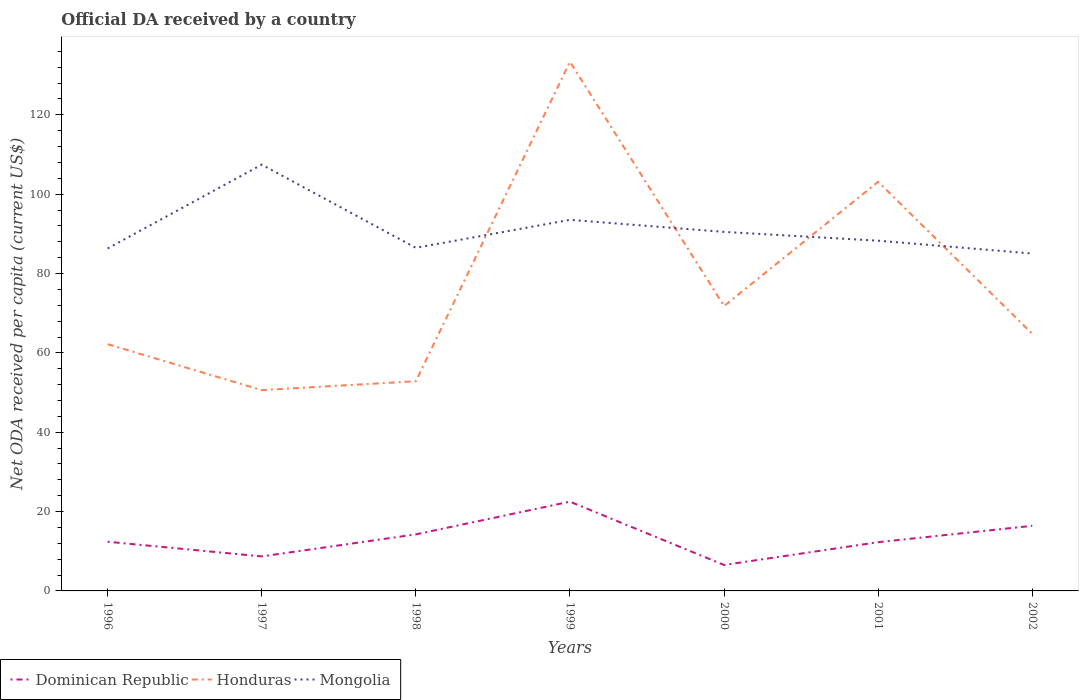How many different coloured lines are there?
Your response must be concise. 3. Does the line corresponding to Dominican Republic intersect with the line corresponding to Mongolia?
Provide a succinct answer. No. Across all years, what is the maximum ODA received in in Honduras?
Ensure brevity in your answer.  50.61. What is the total ODA received in in Mongolia in the graph?
Provide a short and direct response. 1.44. What is the difference between the highest and the second highest ODA received in in Mongolia?
Provide a succinct answer. 22.4. What is the difference between the highest and the lowest ODA received in in Dominican Republic?
Ensure brevity in your answer.  3. How many lines are there?
Make the answer very short. 3. What is the difference between two consecutive major ticks on the Y-axis?
Provide a succinct answer. 20. Does the graph contain any zero values?
Ensure brevity in your answer.  No. Where does the legend appear in the graph?
Ensure brevity in your answer.  Bottom left. How many legend labels are there?
Make the answer very short. 3. What is the title of the graph?
Your response must be concise. Official DA received by a country. What is the label or title of the X-axis?
Give a very brief answer. Years. What is the label or title of the Y-axis?
Keep it short and to the point. Net ODA received per capita (current US$). What is the Net ODA received per capita (current US$) in Dominican Republic in 1996?
Make the answer very short. 12.39. What is the Net ODA received per capita (current US$) in Honduras in 1996?
Provide a succinct answer. 62.19. What is the Net ODA received per capita (current US$) in Mongolia in 1996?
Offer a terse response. 86.32. What is the Net ODA received per capita (current US$) in Dominican Republic in 1997?
Your response must be concise. 8.7. What is the Net ODA received per capita (current US$) in Honduras in 1997?
Give a very brief answer. 50.61. What is the Net ODA received per capita (current US$) of Mongolia in 1997?
Provide a short and direct response. 107.45. What is the Net ODA received per capita (current US$) in Dominican Republic in 1998?
Give a very brief answer. 14.25. What is the Net ODA received per capita (current US$) in Honduras in 1998?
Keep it short and to the point. 52.86. What is the Net ODA received per capita (current US$) of Mongolia in 1998?
Make the answer very short. 86.48. What is the Net ODA received per capita (current US$) of Dominican Republic in 1999?
Give a very brief answer. 22.5. What is the Net ODA received per capita (current US$) of Honduras in 1999?
Make the answer very short. 133.39. What is the Net ODA received per capita (current US$) in Mongolia in 1999?
Offer a very short reply. 93.54. What is the Net ODA received per capita (current US$) of Dominican Republic in 2000?
Your answer should be compact. 6.54. What is the Net ODA received per capita (current US$) in Honduras in 2000?
Provide a short and direct response. 71.81. What is the Net ODA received per capita (current US$) in Mongolia in 2000?
Your answer should be compact. 90.5. What is the Net ODA received per capita (current US$) of Dominican Republic in 2001?
Your answer should be compact. 12.29. What is the Net ODA received per capita (current US$) of Honduras in 2001?
Your answer should be compact. 103.13. What is the Net ODA received per capita (current US$) of Mongolia in 2001?
Your response must be concise. 88.28. What is the Net ODA received per capita (current US$) in Dominican Republic in 2002?
Ensure brevity in your answer.  16.41. What is the Net ODA received per capita (current US$) of Honduras in 2002?
Keep it short and to the point. 64.8. What is the Net ODA received per capita (current US$) of Mongolia in 2002?
Your answer should be very brief. 85.04. Across all years, what is the maximum Net ODA received per capita (current US$) of Dominican Republic?
Give a very brief answer. 22.5. Across all years, what is the maximum Net ODA received per capita (current US$) in Honduras?
Your answer should be very brief. 133.39. Across all years, what is the maximum Net ODA received per capita (current US$) of Mongolia?
Offer a terse response. 107.45. Across all years, what is the minimum Net ODA received per capita (current US$) of Dominican Republic?
Provide a succinct answer. 6.54. Across all years, what is the minimum Net ODA received per capita (current US$) in Honduras?
Provide a succinct answer. 50.61. Across all years, what is the minimum Net ODA received per capita (current US$) of Mongolia?
Provide a succinct answer. 85.04. What is the total Net ODA received per capita (current US$) in Dominican Republic in the graph?
Provide a short and direct response. 93.08. What is the total Net ODA received per capita (current US$) of Honduras in the graph?
Give a very brief answer. 538.78. What is the total Net ODA received per capita (current US$) of Mongolia in the graph?
Your response must be concise. 637.6. What is the difference between the Net ODA received per capita (current US$) in Dominican Republic in 1996 and that in 1997?
Provide a short and direct response. 3.7. What is the difference between the Net ODA received per capita (current US$) in Honduras in 1996 and that in 1997?
Offer a terse response. 11.58. What is the difference between the Net ODA received per capita (current US$) of Mongolia in 1996 and that in 1997?
Your answer should be compact. -21.12. What is the difference between the Net ODA received per capita (current US$) of Dominican Republic in 1996 and that in 1998?
Ensure brevity in your answer.  -1.86. What is the difference between the Net ODA received per capita (current US$) in Honduras in 1996 and that in 1998?
Offer a terse response. 9.34. What is the difference between the Net ODA received per capita (current US$) of Mongolia in 1996 and that in 1998?
Provide a succinct answer. -0.16. What is the difference between the Net ODA received per capita (current US$) in Dominican Republic in 1996 and that in 1999?
Keep it short and to the point. -10.1. What is the difference between the Net ODA received per capita (current US$) in Honduras in 1996 and that in 1999?
Make the answer very short. -71.19. What is the difference between the Net ODA received per capita (current US$) in Mongolia in 1996 and that in 1999?
Make the answer very short. -7.22. What is the difference between the Net ODA received per capita (current US$) of Dominican Republic in 1996 and that in 2000?
Give a very brief answer. 5.85. What is the difference between the Net ODA received per capita (current US$) of Honduras in 1996 and that in 2000?
Provide a succinct answer. -9.61. What is the difference between the Net ODA received per capita (current US$) in Mongolia in 1996 and that in 2000?
Your answer should be very brief. -4.18. What is the difference between the Net ODA received per capita (current US$) in Dominican Republic in 1996 and that in 2001?
Your answer should be compact. 0.11. What is the difference between the Net ODA received per capita (current US$) in Honduras in 1996 and that in 2001?
Your answer should be very brief. -40.94. What is the difference between the Net ODA received per capita (current US$) in Mongolia in 1996 and that in 2001?
Make the answer very short. -1.96. What is the difference between the Net ODA received per capita (current US$) of Dominican Republic in 1996 and that in 2002?
Your answer should be very brief. -4.02. What is the difference between the Net ODA received per capita (current US$) of Honduras in 1996 and that in 2002?
Offer a terse response. -2.6. What is the difference between the Net ODA received per capita (current US$) in Mongolia in 1996 and that in 2002?
Your response must be concise. 1.28. What is the difference between the Net ODA received per capita (current US$) in Dominican Republic in 1997 and that in 1998?
Ensure brevity in your answer.  -5.55. What is the difference between the Net ODA received per capita (current US$) of Honduras in 1997 and that in 1998?
Your response must be concise. -2.25. What is the difference between the Net ODA received per capita (current US$) in Mongolia in 1997 and that in 1998?
Make the answer very short. 20.97. What is the difference between the Net ODA received per capita (current US$) of Dominican Republic in 1997 and that in 1999?
Your response must be concise. -13.8. What is the difference between the Net ODA received per capita (current US$) in Honduras in 1997 and that in 1999?
Offer a terse response. -82.78. What is the difference between the Net ODA received per capita (current US$) of Mongolia in 1997 and that in 1999?
Give a very brief answer. 13.91. What is the difference between the Net ODA received per capita (current US$) of Dominican Republic in 1997 and that in 2000?
Make the answer very short. 2.16. What is the difference between the Net ODA received per capita (current US$) of Honduras in 1997 and that in 2000?
Provide a short and direct response. -21.2. What is the difference between the Net ODA received per capita (current US$) in Mongolia in 1997 and that in 2000?
Keep it short and to the point. 16.95. What is the difference between the Net ODA received per capita (current US$) of Dominican Republic in 1997 and that in 2001?
Your response must be concise. -3.59. What is the difference between the Net ODA received per capita (current US$) of Honduras in 1997 and that in 2001?
Your answer should be very brief. -52.52. What is the difference between the Net ODA received per capita (current US$) of Mongolia in 1997 and that in 2001?
Offer a very short reply. 19.17. What is the difference between the Net ODA received per capita (current US$) in Dominican Republic in 1997 and that in 2002?
Give a very brief answer. -7.71. What is the difference between the Net ODA received per capita (current US$) of Honduras in 1997 and that in 2002?
Your answer should be very brief. -14.19. What is the difference between the Net ODA received per capita (current US$) in Mongolia in 1997 and that in 2002?
Offer a very short reply. 22.4. What is the difference between the Net ODA received per capita (current US$) of Dominican Republic in 1998 and that in 1999?
Make the answer very short. -8.25. What is the difference between the Net ODA received per capita (current US$) in Honduras in 1998 and that in 1999?
Provide a succinct answer. -80.53. What is the difference between the Net ODA received per capita (current US$) of Mongolia in 1998 and that in 1999?
Provide a short and direct response. -7.06. What is the difference between the Net ODA received per capita (current US$) in Dominican Republic in 1998 and that in 2000?
Give a very brief answer. 7.71. What is the difference between the Net ODA received per capita (current US$) in Honduras in 1998 and that in 2000?
Provide a short and direct response. -18.95. What is the difference between the Net ODA received per capita (current US$) in Mongolia in 1998 and that in 2000?
Give a very brief answer. -4.02. What is the difference between the Net ODA received per capita (current US$) in Dominican Republic in 1998 and that in 2001?
Ensure brevity in your answer.  1.96. What is the difference between the Net ODA received per capita (current US$) in Honduras in 1998 and that in 2001?
Ensure brevity in your answer.  -50.27. What is the difference between the Net ODA received per capita (current US$) in Mongolia in 1998 and that in 2001?
Provide a short and direct response. -1.8. What is the difference between the Net ODA received per capita (current US$) in Dominican Republic in 1998 and that in 2002?
Your response must be concise. -2.16. What is the difference between the Net ODA received per capita (current US$) in Honduras in 1998 and that in 2002?
Your answer should be very brief. -11.94. What is the difference between the Net ODA received per capita (current US$) in Mongolia in 1998 and that in 2002?
Your response must be concise. 1.44. What is the difference between the Net ODA received per capita (current US$) of Dominican Republic in 1999 and that in 2000?
Make the answer very short. 15.96. What is the difference between the Net ODA received per capita (current US$) of Honduras in 1999 and that in 2000?
Offer a terse response. 61.58. What is the difference between the Net ODA received per capita (current US$) in Mongolia in 1999 and that in 2000?
Offer a terse response. 3.04. What is the difference between the Net ODA received per capita (current US$) of Dominican Republic in 1999 and that in 2001?
Ensure brevity in your answer.  10.21. What is the difference between the Net ODA received per capita (current US$) in Honduras in 1999 and that in 2001?
Offer a very short reply. 30.26. What is the difference between the Net ODA received per capita (current US$) in Mongolia in 1999 and that in 2001?
Offer a very short reply. 5.26. What is the difference between the Net ODA received per capita (current US$) in Dominican Republic in 1999 and that in 2002?
Give a very brief answer. 6.09. What is the difference between the Net ODA received per capita (current US$) in Honduras in 1999 and that in 2002?
Make the answer very short. 68.59. What is the difference between the Net ODA received per capita (current US$) in Mongolia in 1999 and that in 2002?
Keep it short and to the point. 8.5. What is the difference between the Net ODA received per capita (current US$) in Dominican Republic in 2000 and that in 2001?
Provide a succinct answer. -5.75. What is the difference between the Net ODA received per capita (current US$) of Honduras in 2000 and that in 2001?
Offer a terse response. -31.32. What is the difference between the Net ODA received per capita (current US$) of Mongolia in 2000 and that in 2001?
Your response must be concise. 2.22. What is the difference between the Net ODA received per capita (current US$) in Dominican Republic in 2000 and that in 2002?
Offer a terse response. -9.87. What is the difference between the Net ODA received per capita (current US$) of Honduras in 2000 and that in 2002?
Offer a terse response. 7.01. What is the difference between the Net ODA received per capita (current US$) in Mongolia in 2000 and that in 2002?
Ensure brevity in your answer.  5.45. What is the difference between the Net ODA received per capita (current US$) of Dominican Republic in 2001 and that in 2002?
Offer a very short reply. -4.13. What is the difference between the Net ODA received per capita (current US$) in Honduras in 2001 and that in 2002?
Your response must be concise. 38.33. What is the difference between the Net ODA received per capita (current US$) in Mongolia in 2001 and that in 2002?
Provide a short and direct response. 3.24. What is the difference between the Net ODA received per capita (current US$) in Dominican Republic in 1996 and the Net ODA received per capita (current US$) in Honduras in 1997?
Offer a very short reply. -38.22. What is the difference between the Net ODA received per capita (current US$) of Dominican Republic in 1996 and the Net ODA received per capita (current US$) of Mongolia in 1997?
Provide a short and direct response. -95.05. What is the difference between the Net ODA received per capita (current US$) of Honduras in 1996 and the Net ODA received per capita (current US$) of Mongolia in 1997?
Ensure brevity in your answer.  -45.25. What is the difference between the Net ODA received per capita (current US$) of Dominican Republic in 1996 and the Net ODA received per capita (current US$) of Honduras in 1998?
Give a very brief answer. -40.46. What is the difference between the Net ODA received per capita (current US$) of Dominican Republic in 1996 and the Net ODA received per capita (current US$) of Mongolia in 1998?
Provide a short and direct response. -74.09. What is the difference between the Net ODA received per capita (current US$) in Honduras in 1996 and the Net ODA received per capita (current US$) in Mongolia in 1998?
Your response must be concise. -24.29. What is the difference between the Net ODA received per capita (current US$) of Dominican Republic in 1996 and the Net ODA received per capita (current US$) of Honduras in 1999?
Provide a succinct answer. -120.99. What is the difference between the Net ODA received per capita (current US$) of Dominican Republic in 1996 and the Net ODA received per capita (current US$) of Mongolia in 1999?
Ensure brevity in your answer.  -81.14. What is the difference between the Net ODA received per capita (current US$) in Honduras in 1996 and the Net ODA received per capita (current US$) in Mongolia in 1999?
Your response must be concise. -31.34. What is the difference between the Net ODA received per capita (current US$) in Dominican Republic in 1996 and the Net ODA received per capita (current US$) in Honduras in 2000?
Ensure brevity in your answer.  -59.41. What is the difference between the Net ODA received per capita (current US$) of Dominican Republic in 1996 and the Net ODA received per capita (current US$) of Mongolia in 2000?
Your answer should be compact. -78.1. What is the difference between the Net ODA received per capita (current US$) in Honduras in 1996 and the Net ODA received per capita (current US$) in Mongolia in 2000?
Provide a succinct answer. -28.3. What is the difference between the Net ODA received per capita (current US$) in Dominican Republic in 1996 and the Net ODA received per capita (current US$) in Honduras in 2001?
Provide a short and direct response. -90.74. What is the difference between the Net ODA received per capita (current US$) of Dominican Republic in 1996 and the Net ODA received per capita (current US$) of Mongolia in 2001?
Your response must be concise. -75.88. What is the difference between the Net ODA received per capita (current US$) in Honduras in 1996 and the Net ODA received per capita (current US$) in Mongolia in 2001?
Offer a terse response. -26.09. What is the difference between the Net ODA received per capita (current US$) in Dominican Republic in 1996 and the Net ODA received per capita (current US$) in Honduras in 2002?
Give a very brief answer. -52.4. What is the difference between the Net ODA received per capita (current US$) of Dominican Republic in 1996 and the Net ODA received per capita (current US$) of Mongolia in 2002?
Provide a succinct answer. -72.65. What is the difference between the Net ODA received per capita (current US$) in Honduras in 1996 and the Net ODA received per capita (current US$) in Mongolia in 2002?
Your answer should be very brief. -22.85. What is the difference between the Net ODA received per capita (current US$) of Dominican Republic in 1997 and the Net ODA received per capita (current US$) of Honduras in 1998?
Offer a very short reply. -44.16. What is the difference between the Net ODA received per capita (current US$) in Dominican Republic in 1997 and the Net ODA received per capita (current US$) in Mongolia in 1998?
Your response must be concise. -77.78. What is the difference between the Net ODA received per capita (current US$) in Honduras in 1997 and the Net ODA received per capita (current US$) in Mongolia in 1998?
Give a very brief answer. -35.87. What is the difference between the Net ODA received per capita (current US$) of Dominican Republic in 1997 and the Net ODA received per capita (current US$) of Honduras in 1999?
Keep it short and to the point. -124.69. What is the difference between the Net ODA received per capita (current US$) in Dominican Republic in 1997 and the Net ODA received per capita (current US$) in Mongolia in 1999?
Ensure brevity in your answer.  -84.84. What is the difference between the Net ODA received per capita (current US$) in Honduras in 1997 and the Net ODA received per capita (current US$) in Mongolia in 1999?
Provide a short and direct response. -42.93. What is the difference between the Net ODA received per capita (current US$) of Dominican Republic in 1997 and the Net ODA received per capita (current US$) of Honduras in 2000?
Your answer should be compact. -63.11. What is the difference between the Net ODA received per capita (current US$) in Dominican Republic in 1997 and the Net ODA received per capita (current US$) in Mongolia in 2000?
Keep it short and to the point. -81.8. What is the difference between the Net ODA received per capita (current US$) in Honduras in 1997 and the Net ODA received per capita (current US$) in Mongolia in 2000?
Offer a very short reply. -39.89. What is the difference between the Net ODA received per capita (current US$) in Dominican Republic in 1997 and the Net ODA received per capita (current US$) in Honduras in 2001?
Ensure brevity in your answer.  -94.43. What is the difference between the Net ODA received per capita (current US$) of Dominican Republic in 1997 and the Net ODA received per capita (current US$) of Mongolia in 2001?
Offer a very short reply. -79.58. What is the difference between the Net ODA received per capita (current US$) in Honduras in 1997 and the Net ODA received per capita (current US$) in Mongolia in 2001?
Provide a short and direct response. -37.67. What is the difference between the Net ODA received per capita (current US$) in Dominican Republic in 1997 and the Net ODA received per capita (current US$) in Honduras in 2002?
Keep it short and to the point. -56.1. What is the difference between the Net ODA received per capita (current US$) in Dominican Republic in 1997 and the Net ODA received per capita (current US$) in Mongolia in 2002?
Your answer should be very brief. -76.34. What is the difference between the Net ODA received per capita (current US$) in Honduras in 1997 and the Net ODA received per capita (current US$) in Mongolia in 2002?
Your response must be concise. -34.43. What is the difference between the Net ODA received per capita (current US$) in Dominican Republic in 1998 and the Net ODA received per capita (current US$) in Honduras in 1999?
Give a very brief answer. -119.13. What is the difference between the Net ODA received per capita (current US$) of Dominican Republic in 1998 and the Net ODA received per capita (current US$) of Mongolia in 1999?
Your response must be concise. -79.29. What is the difference between the Net ODA received per capita (current US$) in Honduras in 1998 and the Net ODA received per capita (current US$) in Mongolia in 1999?
Ensure brevity in your answer.  -40.68. What is the difference between the Net ODA received per capita (current US$) of Dominican Republic in 1998 and the Net ODA received per capita (current US$) of Honduras in 2000?
Offer a very short reply. -57.56. What is the difference between the Net ODA received per capita (current US$) in Dominican Republic in 1998 and the Net ODA received per capita (current US$) in Mongolia in 2000?
Offer a terse response. -76.25. What is the difference between the Net ODA received per capita (current US$) in Honduras in 1998 and the Net ODA received per capita (current US$) in Mongolia in 2000?
Your response must be concise. -37.64. What is the difference between the Net ODA received per capita (current US$) in Dominican Republic in 1998 and the Net ODA received per capita (current US$) in Honduras in 2001?
Ensure brevity in your answer.  -88.88. What is the difference between the Net ODA received per capita (current US$) in Dominican Republic in 1998 and the Net ODA received per capita (current US$) in Mongolia in 2001?
Keep it short and to the point. -74.03. What is the difference between the Net ODA received per capita (current US$) of Honduras in 1998 and the Net ODA received per capita (current US$) of Mongolia in 2001?
Offer a very short reply. -35.42. What is the difference between the Net ODA received per capita (current US$) in Dominican Republic in 1998 and the Net ODA received per capita (current US$) in Honduras in 2002?
Provide a succinct answer. -50.55. What is the difference between the Net ODA received per capita (current US$) of Dominican Republic in 1998 and the Net ODA received per capita (current US$) of Mongolia in 2002?
Keep it short and to the point. -70.79. What is the difference between the Net ODA received per capita (current US$) of Honduras in 1998 and the Net ODA received per capita (current US$) of Mongolia in 2002?
Provide a succinct answer. -32.19. What is the difference between the Net ODA received per capita (current US$) of Dominican Republic in 1999 and the Net ODA received per capita (current US$) of Honduras in 2000?
Your answer should be very brief. -49.31. What is the difference between the Net ODA received per capita (current US$) of Dominican Republic in 1999 and the Net ODA received per capita (current US$) of Mongolia in 2000?
Your answer should be compact. -68. What is the difference between the Net ODA received per capita (current US$) of Honduras in 1999 and the Net ODA received per capita (current US$) of Mongolia in 2000?
Give a very brief answer. 42.89. What is the difference between the Net ODA received per capita (current US$) of Dominican Republic in 1999 and the Net ODA received per capita (current US$) of Honduras in 2001?
Provide a succinct answer. -80.63. What is the difference between the Net ODA received per capita (current US$) in Dominican Republic in 1999 and the Net ODA received per capita (current US$) in Mongolia in 2001?
Provide a short and direct response. -65.78. What is the difference between the Net ODA received per capita (current US$) of Honduras in 1999 and the Net ODA received per capita (current US$) of Mongolia in 2001?
Keep it short and to the point. 45.11. What is the difference between the Net ODA received per capita (current US$) of Dominican Republic in 1999 and the Net ODA received per capita (current US$) of Honduras in 2002?
Your answer should be compact. -42.3. What is the difference between the Net ODA received per capita (current US$) of Dominican Republic in 1999 and the Net ODA received per capita (current US$) of Mongolia in 2002?
Your response must be concise. -62.54. What is the difference between the Net ODA received per capita (current US$) of Honduras in 1999 and the Net ODA received per capita (current US$) of Mongolia in 2002?
Offer a terse response. 48.34. What is the difference between the Net ODA received per capita (current US$) in Dominican Republic in 2000 and the Net ODA received per capita (current US$) in Honduras in 2001?
Your answer should be very brief. -96.59. What is the difference between the Net ODA received per capita (current US$) of Dominican Republic in 2000 and the Net ODA received per capita (current US$) of Mongolia in 2001?
Keep it short and to the point. -81.74. What is the difference between the Net ODA received per capita (current US$) of Honduras in 2000 and the Net ODA received per capita (current US$) of Mongolia in 2001?
Make the answer very short. -16.47. What is the difference between the Net ODA received per capita (current US$) in Dominican Republic in 2000 and the Net ODA received per capita (current US$) in Honduras in 2002?
Offer a terse response. -58.26. What is the difference between the Net ODA received per capita (current US$) of Dominican Republic in 2000 and the Net ODA received per capita (current US$) of Mongolia in 2002?
Keep it short and to the point. -78.5. What is the difference between the Net ODA received per capita (current US$) of Honduras in 2000 and the Net ODA received per capita (current US$) of Mongolia in 2002?
Your response must be concise. -13.24. What is the difference between the Net ODA received per capita (current US$) of Dominican Republic in 2001 and the Net ODA received per capita (current US$) of Honduras in 2002?
Provide a short and direct response. -52.51. What is the difference between the Net ODA received per capita (current US$) of Dominican Republic in 2001 and the Net ODA received per capita (current US$) of Mongolia in 2002?
Ensure brevity in your answer.  -72.75. What is the difference between the Net ODA received per capita (current US$) in Honduras in 2001 and the Net ODA received per capita (current US$) in Mongolia in 2002?
Make the answer very short. 18.09. What is the average Net ODA received per capita (current US$) in Dominican Republic per year?
Provide a short and direct response. 13.3. What is the average Net ODA received per capita (current US$) in Honduras per year?
Give a very brief answer. 76.97. What is the average Net ODA received per capita (current US$) in Mongolia per year?
Give a very brief answer. 91.09. In the year 1996, what is the difference between the Net ODA received per capita (current US$) in Dominican Republic and Net ODA received per capita (current US$) in Honduras?
Offer a terse response. -49.8. In the year 1996, what is the difference between the Net ODA received per capita (current US$) of Dominican Republic and Net ODA received per capita (current US$) of Mongolia?
Provide a succinct answer. -73.93. In the year 1996, what is the difference between the Net ODA received per capita (current US$) in Honduras and Net ODA received per capita (current US$) in Mongolia?
Make the answer very short. -24.13. In the year 1997, what is the difference between the Net ODA received per capita (current US$) of Dominican Republic and Net ODA received per capita (current US$) of Honduras?
Provide a succinct answer. -41.91. In the year 1997, what is the difference between the Net ODA received per capita (current US$) of Dominican Republic and Net ODA received per capita (current US$) of Mongolia?
Your answer should be compact. -98.75. In the year 1997, what is the difference between the Net ODA received per capita (current US$) in Honduras and Net ODA received per capita (current US$) in Mongolia?
Provide a succinct answer. -56.84. In the year 1998, what is the difference between the Net ODA received per capita (current US$) of Dominican Republic and Net ODA received per capita (current US$) of Honduras?
Your answer should be compact. -38.61. In the year 1998, what is the difference between the Net ODA received per capita (current US$) of Dominican Republic and Net ODA received per capita (current US$) of Mongolia?
Your answer should be very brief. -72.23. In the year 1998, what is the difference between the Net ODA received per capita (current US$) of Honduras and Net ODA received per capita (current US$) of Mongolia?
Ensure brevity in your answer.  -33.62. In the year 1999, what is the difference between the Net ODA received per capita (current US$) of Dominican Republic and Net ODA received per capita (current US$) of Honduras?
Offer a very short reply. -110.89. In the year 1999, what is the difference between the Net ODA received per capita (current US$) in Dominican Republic and Net ODA received per capita (current US$) in Mongolia?
Give a very brief answer. -71.04. In the year 1999, what is the difference between the Net ODA received per capita (current US$) of Honduras and Net ODA received per capita (current US$) of Mongolia?
Give a very brief answer. 39.85. In the year 2000, what is the difference between the Net ODA received per capita (current US$) in Dominican Republic and Net ODA received per capita (current US$) in Honduras?
Offer a very short reply. -65.27. In the year 2000, what is the difference between the Net ODA received per capita (current US$) in Dominican Republic and Net ODA received per capita (current US$) in Mongolia?
Ensure brevity in your answer.  -83.96. In the year 2000, what is the difference between the Net ODA received per capita (current US$) of Honduras and Net ODA received per capita (current US$) of Mongolia?
Make the answer very short. -18.69. In the year 2001, what is the difference between the Net ODA received per capita (current US$) in Dominican Republic and Net ODA received per capita (current US$) in Honduras?
Your answer should be compact. -90.84. In the year 2001, what is the difference between the Net ODA received per capita (current US$) of Dominican Republic and Net ODA received per capita (current US$) of Mongolia?
Offer a very short reply. -75.99. In the year 2001, what is the difference between the Net ODA received per capita (current US$) of Honduras and Net ODA received per capita (current US$) of Mongolia?
Offer a terse response. 14.85. In the year 2002, what is the difference between the Net ODA received per capita (current US$) in Dominican Republic and Net ODA received per capita (current US$) in Honduras?
Your answer should be compact. -48.39. In the year 2002, what is the difference between the Net ODA received per capita (current US$) of Dominican Republic and Net ODA received per capita (current US$) of Mongolia?
Provide a succinct answer. -68.63. In the year 2002, what is the difference between the Net ODA received per capita (current US$) of Honduras and Net ODA received per capita (current US$) of Mongolia?
Offer a very short reply. -20.24. What is the ratio of the Net ODA received per capita (current US$) of Dominican Republic in 1996 to that in 1997?
Provide a short and direct response. 1.42. What is the ratio of the Net ODA received per capita (current US$) of Honduras in 1996 to that in 1997?
Keep it short and to the point. 1.23. What is the ratio of the Net ODA received per capita (current US$) in Mongolia in 1996 to that in 1997?
Give a very brief answer. 0.8. What is the ratio of the Net ODA received per capita (current US$) in Dominican Republic in 1996 to that in 1998?
Your answer should be very brief. 0.87. What is the ratio of the Net ODA received per capita (current US$) of Honduras in 1996 to that in 1998?
Ensure brevity in your answer.  1.18. What is the ratio of the Net ODA received per capita (current US$) of Dominican Republic in 1996 to that in 1999?
Provide a short and direct response. 0.55. What is the ratio of the Net ODA received per capita (current US$) of Honduras in 1996 to that in 1999?
Ensure brevity in your answer.  0.47. What is the ratio of the Net ODA received per capita (current US$) of Mongolia in 1996 to that in 1999?
Provide a short and direct response. 0.92. What is the ratio of the Net ODA received per capita (current US$) of Dominican Republic in 1996 to that in 2000?
Make the answer very short. 1.9. What is the ratio of the Net ODA received per capita (current US$) in Honduras in 1996 to that in 2000?
Give a very brief answer. 0.87. What is the ratio of the Net ODA received per capita (current US$) in Mongolia in 1996 to that in 2000?
Your response must be concise. 0.95. What is the ratio of the Net ODA received per capita (current US$) in Dominican Republic in 1996 to that in 2001?
Give a very brief answer. 1.01. What is the ratio of the Net ODA received per capita (current US$) in Honduras in 1996 to that in 2001?
Keep it short and to the point. 0.6. What is the ratio of the Net ODA received per capita (current US$) in Mongolia in 1996 to that in 2001?
Provide a succinct answer. 0.98. What is the ratio of the Net ODA received per capita (current US$) of Dominican Republic in 1996 to that in 2002?
Offer a terse response. 0.76. What is the ratio of the Net ODA received per capita (current US$) of Honduras in 1996 to that in 2002?
Offer a very short reply. 0.96. What is the ratio of the Net ODA received per capita (current US$) of Dominican Republic in 1997 to that in 1998?
Your answer should be very brief. 0.61. What is the ratio of the Net ODA received per capita (current US$) in Honduras in 1997 to that in 1998?
Keep it short and to the point. 0.96. What is the ratio of the Net ODA received per capita (current US$) in Mongolia in 1997 to that in 1998?
Offer a very short reply. 1.24. What is the ratio of the Net ODA received per capita (current US$) of Dominican Republic in 1997 to that in 1999?
Provide a short and direct response. 0.39. What is the ratio of the Net ODA received per capita (current US$) of Honduras in 1997 to that in 1999?
Ensure brevity in your answer.  0.38. What is the ratio of the Net ODA received per capita (current US$) in Mongolia in 1997 to that in 1999?
Ensure brevity in your answer.  1.15. What is the ratio of the Net ODA received per capita (current US$) in Dominican Republic in 1997 to that in 2000?
Keep it short and to the point. 1.33. What is the ratio of the Net ODA received per capita (current US$) in Honduras in 1997 to that in 2000?
Offer a terse response. 0.7. What is the ratio of the Net ODA received per capita (current US$) in Mongolia in 1997 to that in 2000?
Make the answer very short. 1.19. What is the ratio of the Net ODA received per capita (current US$) in Dominican Republic in 1997 to that in 2001?
Your response must be concise. 0.71. What is the ratio of the Net ODA received per capita (current US$) of Honduras in 1997 to that in 2001?
Provide a short and direct response. 0.49. What is the ratio of the Net ODA received per capita (current US$) of Mongolia in 1997 to that in 2001?
Your answer should be very brief. 1.22. What is the ratio of the Net ODA received per capita (current US$) in Dominican Republic in 1997 to that in 2002?
Your response must be concise. 0.53. What is the ratio of the Net ODA received per capita (current US$) in Honduras in 1997 to that in 2002?
Offer a very short reply. 0.78. What is the ratio of the Net ODA received per capita (current US$) in Mongolia in 1997 to that in 2002?
Offer a terse response. 1.26. What is the ratio of the Net ODA received per capita (current US$) in Dominican Republic in 1998 to that in 1999?
Your answer should be compact. 0.63. What is the ratio of the Net ODA received per capita (current US$) of Honduras in 1998 to that in 1999?
Your response must be concise. 0.4. What is the ratio of the Net ODA received per capita (current US$) in Mongolia in 1998 to that in 1999?
Provide a succinct answer. 0.92. What is the ratio of the Net ODA received per capita (current US$) of Dominican Republic in 1998 to that in 2000?
Provide a short and direct response. 2.18. What is the ratio of the Net ODA received per capita (current US$) of Honduras in 1998 to that in 2000?
Keep it short and to the point. 0.74. What is the ratio of the Net ODA received per capita (current US$) in Mongolia in 1998 to that in 2000?
Provide a succinct answer. 0.96. What is the ratio of the Net ODA received per capita (current US$) in Dominican Republic in 1998 to that in 2001?
Your response must be concise. 1.16. What is the ratio of the Net ODA received per capita (current US$) in Honduras in 1998 to that in 2001?
Ensure brevity in your answer.  0.51. What is the ratio of the Net ODA received per capita (current US$) of Mongolia in 1998 to that in 2001?
Keep it short and to the point. 0.98. What is the ratio of the Net ODA received per capita (current US$) in Dominican Republic in 1998 to that in 2002?
Keep it short and to the point. 0.87. What is the ratio of the Net ODA received per capita (current US$) of Honduras in 1998 to that in 2002?
Keep it short and to the point. 0.82. What is the ratio of the Net ODA received per capita (current US$) of Mongolia in 1998 to that in 2002?
Provide a succinct answer. 1.02. What is the ratio of the Net ODA received per capita (current US$) in Dominican Republic in 1999 to that in 2000?
Give a very brief answer. 3.44. What is the ratio of the Net ODA received per capita (current US$) in Honduras in 1999 to that in 2000?
Your response must be concise. 1.86. What is the ratio of the Net ODA received per capita (current US$) of Mongolia in 1999 to that in 2000?
Offer a terse response. 1.03. What is the ratio of the Net ODA received per capita (current US$) in Dominican Republic in 1999 to that in 2001?
Keep it short and to the point. 1.83. What is the ratio of the Net ODA received per capita (current US$) in Honduras in 1999 to that in 2001?
Provide a succinct answer. 1.29. What is the ratio of the Net ODA received per capita (current US$) of Mongolia in 1999 to that in 2001?
Offer a very short reply. 1.06. What is the ratio of the Net ODA received per capita (current US$) of Dominican Republic in 1999 to that in 2002?
Your answer should be compact. 1.37. What is the ratio of the Net ODA received per capita (current US$) of Honduras in 1999 to that in 2002?
Provide a short and direct response. 2.06. What is the ratio of the Net ODA received per capita (current US$) in Mongolia in 1999 to that in 2002?
Your answer should be very brief. 1.1. What is the ratio of the Net ODA received per capita (current US$) of Dominican Republic in 2000 to that in 2001?
Your answer should be very brief. 0.53. What is the ratio of the Net ODA received per capita (current US$) in Honduras in 2000 to that in 2001?
Your answer should be very brief. 0.7. What is the ratio of the Net ODA received per capita (current US$) of Mongolia in 2000 to that in 2001?
Your answer should be compact. 1.03. What is the ratio of the Net ODA received per capita (current US$) in Dominican Republic in 2000 to that in 2002?
Your answer should be compact. 0.4. What is the ratio of the Net ODA received per capita (current US$) of Honduras in 2000 to that in 2002?
Your answer should be very brief. 1.11. What is the ratio of the Net ODA received per capita (current US$) in Mongolia in 2000 to that in 2002?
Your answer should be compact. 1.06. What is the ratio of the Net ODA received per capita (current US$) in Dominican Republic in 2001 to that in 2002?
Provide a short and direct response. 0.75. What is the ratio of the Net ODA received per capita (current US$) of Honduras in 2001 to that in 2002?
Your answer should be compact. 1.59. What is the ratio of the Net ODA received per capita (current US$) in Mongolia in 2001 to that in 2002?
Your response must be concise. 1.04. What is the difference between the highest and the second highest Net ODA received per capita (current US$) in Dominican Republic?
Provide a short and direct response. 6.09. What is the difference between the highest and the second highest Net ODA received per capita (current US$) in Honduras?
Offer a very short reply. 30.26. What is the difference between the highest and the second highest Net ODA received per capita (current US$) of Mongolia?
Offer a terse response. 13.91. What is the difference between the highest and the lowest Net ODA received per capita (current US$) of Dominican Republic?
Your answer should be compact. 15.96. What is the difference between the highest and the lowest Net ODA received per capita (current US$) in Honduras?
Keep it short and to the point. 82.78. What is the difference between the highest and the lowest Net ODA received per capita (current US$) of Mongolia?
Your answer should be very brief. 22.4. 